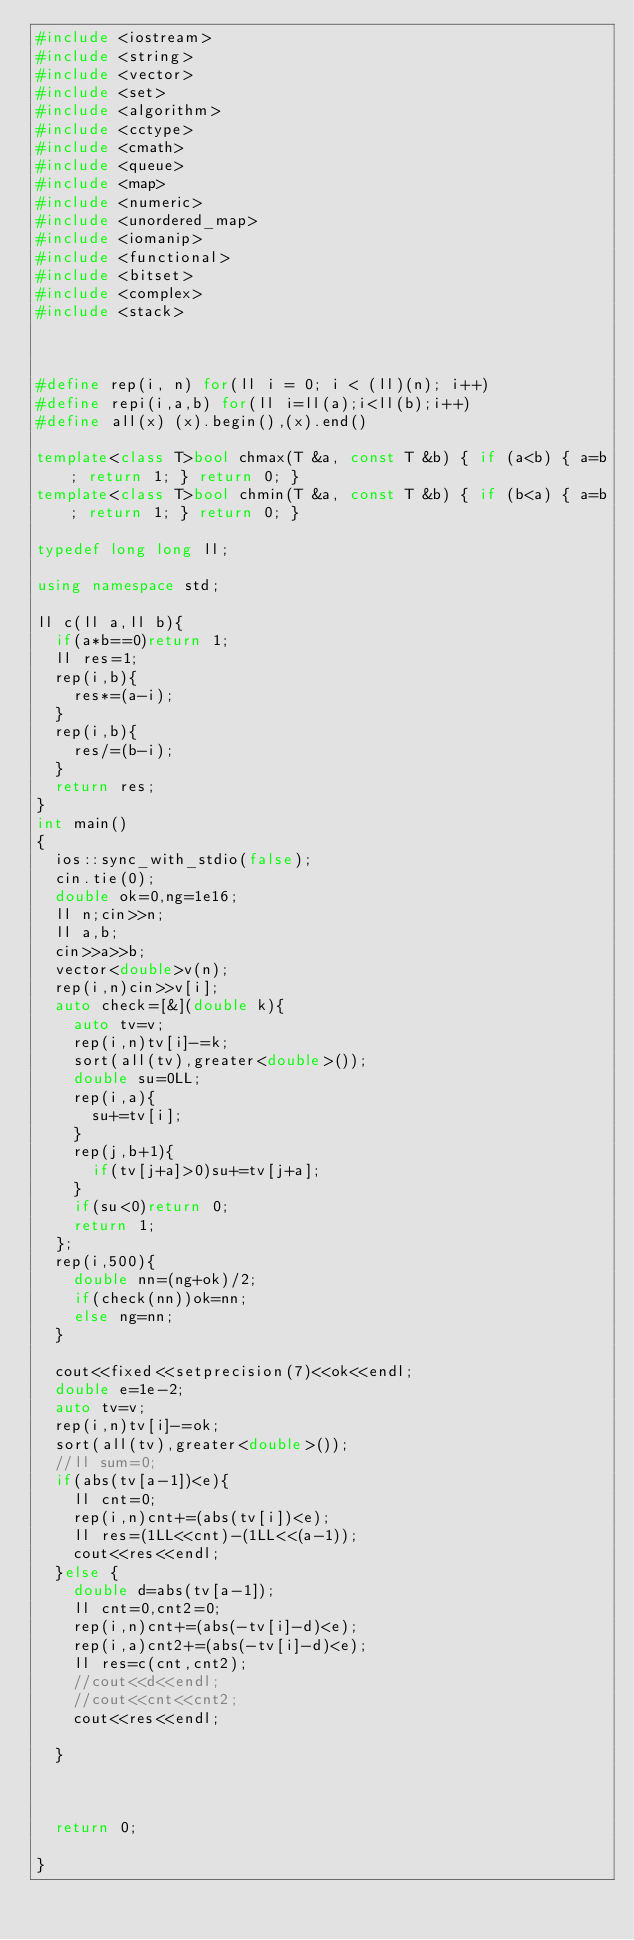Convert code to text. <code><loc_0><loc_0><loc_500><loc_500><_C++_>#include <iostream>
#include <string>
#include <vector>
#include <set>
#include <algorithm>
#include <cctype>
#include <cmath>
#include <queue>
#include <map>
#include <numeric>
#include <unordered_map>
#include <iomanip>
#include <functional>
#include <bitset>
#include <complex>
#include <stack>



#define rep(i, n) for(ll i = 0; i < (ll)(n); i++)
#define repi(i,a,b) for(ll i=ll(a);i<ll(b);i++)
#define all(x) (x).begin(),(x).end()

template<class T>bool chmax(T &a, const T &b) { if (a<b) { a=b; return 1; } return 0; }
template<class T>bool chmin(T &a, const T &b) { if (b<a) { a=b; return 1; } return 0; }

typedef long long ll;

using namespace std;

ll c(ll a,ll b){
  if(a*b==0)return 1;
  ll res=1;
  rep(i,b){
    res*=(a-i);
  }
  rep(i,b){
    res/=(b-i);
  }
  return res;
}
int main()
{
  ios::sync_with_stdio(false);
  cin.tie(0);
  double ok=0,ng=1e16;
  ll n;cin>>n;
  ll a,b;
  cin>>a>>b;
  vector<double>v(n);
  rep(i,n)cin>>v[i];
  auto check=[&](double k){
    auto tv=v;
    rep(i,n)tv[i]-=k;
    sort(all(tv),greater<double>());
    double su=0LL;
    rep(i,a){
      su+=tv[i];
    }
    rep(j,b+1){
      if(tv[j+a]>0)su+=tv[j+a];
    }
    if(su<0)return 0;
    return 1;
  };
  rep(i,500){
    double nn=(ng+ok)/2;
    if(check(nn))ok=nn;
    else ng=nn;
  }

  cout<<fixed<<setprecision(7)<<ok<<endl;
  double e=1e-2;
  auto tv=v;
  rep(i,n)tv[i]-=ok;
  sort(all(tv),greater<double>());
  //ll sum=0;
  if(abs(tv[a-1])<e){
    ll cnt=0;
    rep(i,n)cnt+=(abs(tv[i])<e);
    ll res=(1LL<<cnt)-(1LL<<(a-1));
    cout<<res<<endl;
  }else {
    double d=abs(tv[a-1]);
    ll cnt=0,cnt2=0;
    rep(i,n)cnt+=(abs(-tv[i]-d)<e);
    rep(i,a)cnt2+=(abs(-tv[i]-d)<e);
    ll res=c(cnt,cnt2);
    //cout<<d<<endl;
    //cout<<cnt<<cnt2;
    cout<<res<<endl;

  }



  return 0;

}
</code> 